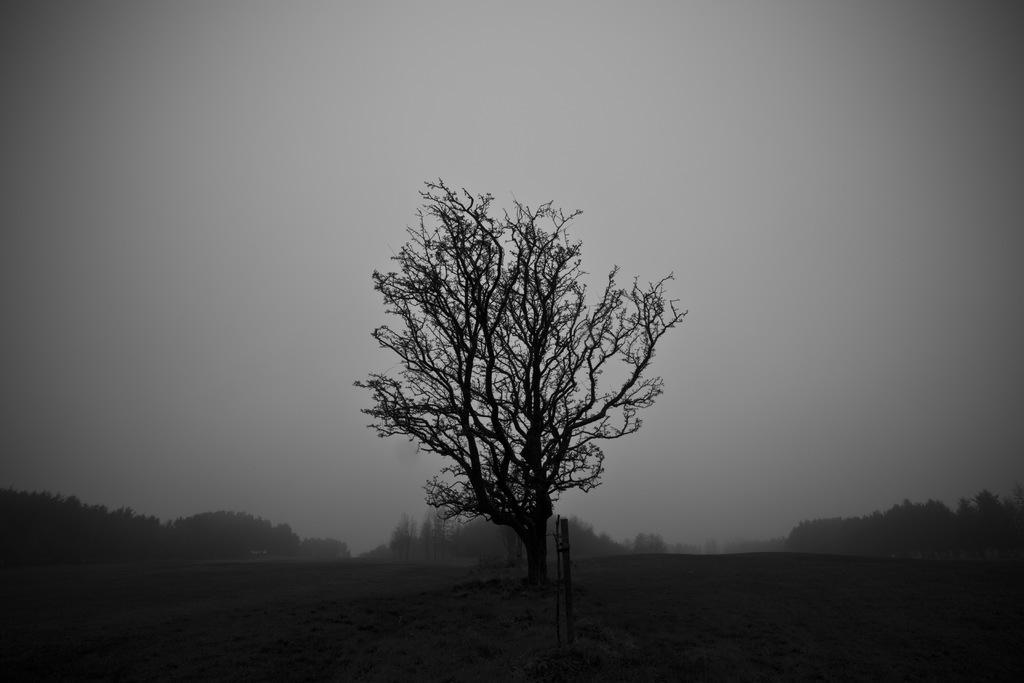Could you give a brief overview of what you see in this image? In the center of the image, we can see a trees and in the background, there are many trees. At the bottom, there is ground. 